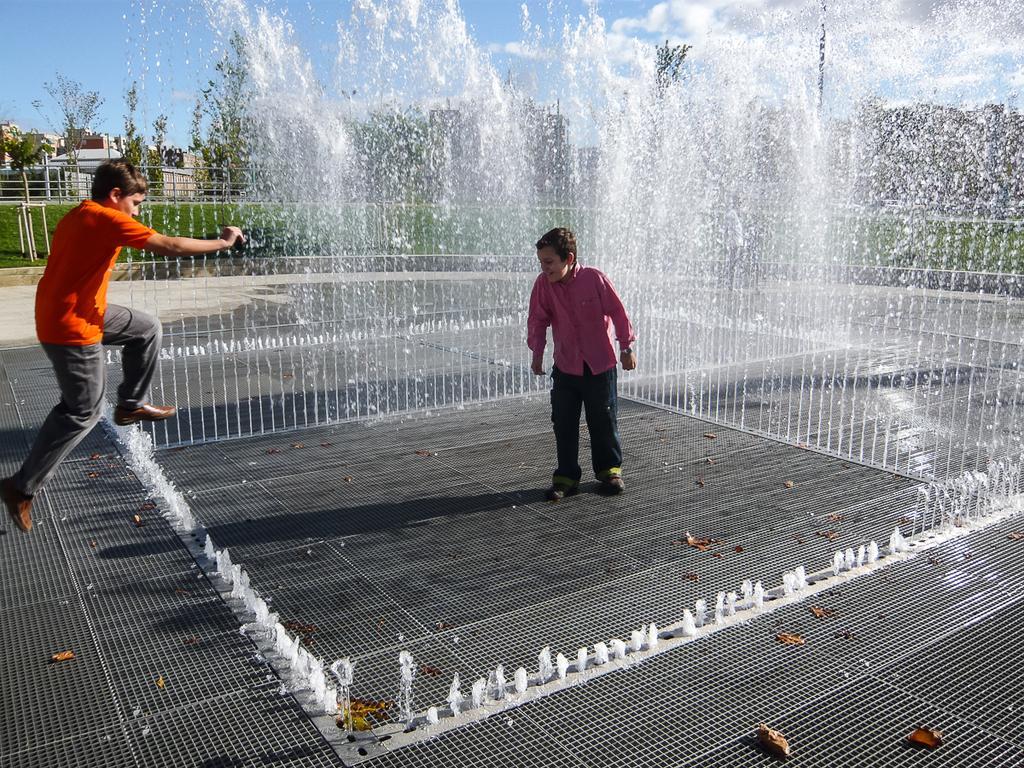Describe this image in one or two sentences. In this picture we can see a boy standing on the floor and in front of him we can see a person jumping, water and at the back of him we can see the grass, trees, buildings and in the background we can see the sky. 